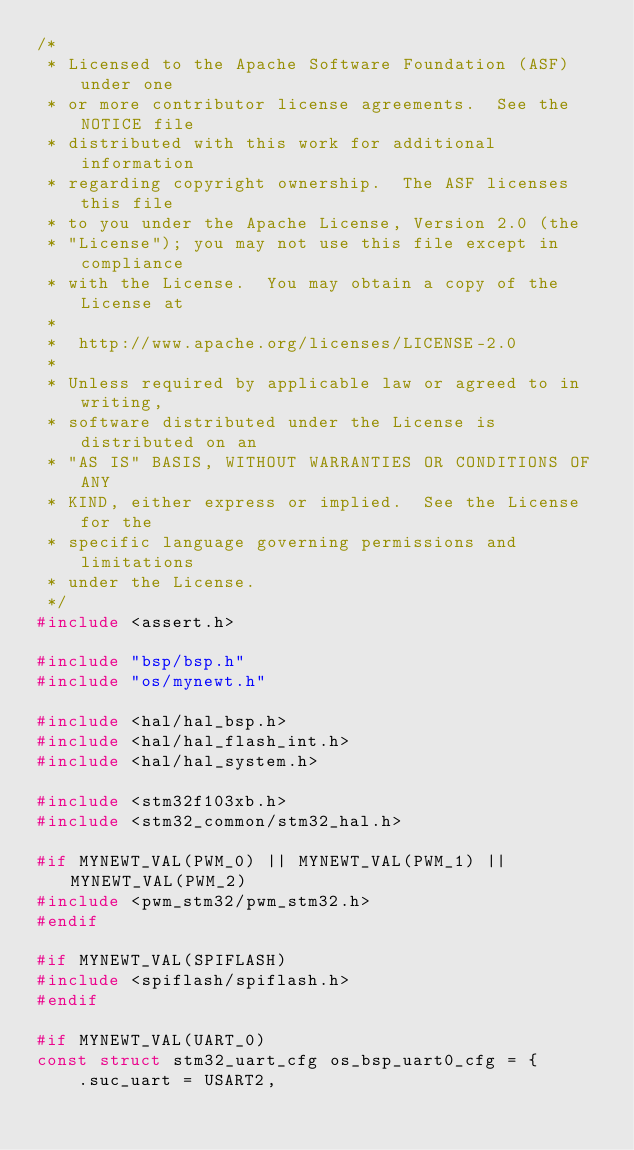Convert code to text. <code><loc_0><loc_0><loc_500><loc_500><_C_>/*
 * Licensed to the Apache Software Foundation (ASF) under one
 * or more contributor license agreements.  See the NOTICE file
 * distributed with this work for additional information
 * regarding copyright ownership.  The ASF licenses this file
 * to you under the Apache License, Version 2.0 (the
 * "License"); you may not use this file except in compliance
 * with the License.  You may obtain a copy of the License at
 *
 *  http://www.apache.org/licenses/LICENSE-2.0
 *
 * Unless required by applicable law or agreed to in writing,
 * software distributed under the License is distributed on an
 * "AS IS" BASIS, WITHOUT WARRANTIES OR CONDITIONS OF ANY
 * KIND, either express or implied.  See the License for the
 * specific language governing permissions and limitations
 * under the License.
 */
#include <assert.h>

#include "bsp/bsp.h"
#include "os/mynewt.h"

#include <hal/hal_bsp.h>
#include <hal/hal_flash_int.h>
#include <hal/hal_system.h>

#include <stm32f103xb.h>
#include <stm32_common/stm32_hal.h>

#if MYNEWT_VAL(PWM_0) || MYNEWT_VAL(PWM_1) || MYNEWT_VAL(PWM_2)
#include <pwm_stm32/pwm_stm32.h>
#endif

#if MYNEWT_VAL(SPIFLASH)
#include <spiflash/spiflash.h>
#endif

#if MYNEWT_VAL(UART_0)
const struct stm32_uart_cfg os_bsp_uart0_cfg = {
    .suc_uart = USART2,</code> 